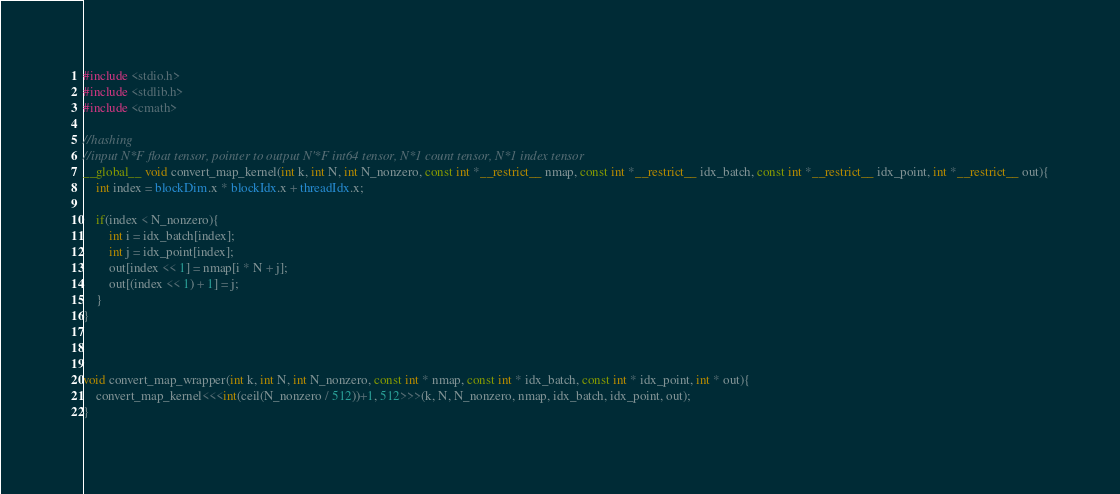<code> <loc_0><loc_0><loc_500><loc_500><_Cuda_>#include <stdio.h>
#include <stdlib.h>
#include <cmath>

//hashing
//input N*F float tensor, pointer to output N'*F int64 tensor, N*1 count tensor, N*1 index tensor
__global__ void convert_map_kernel(int k, int N, int N_nonzero, const int *__restrict__ nmap, const int *__restrict__ idx_batch, const int *__restrict__ idx_point, int *__restrict__ out){
    int index = blockDim.x * blockIdx.x + threadIdx.x;
    
    if(index < N_nonzero){
        int i = idx_batch[index];
        int j = idx_point[index];
        out[index << 1] = nmap[i * N + j];
        out[(index << 1) + 1] = j;
    }
}



void convert_map_wrapper(int k, int N, int N_nonzero, const int * nmap, const int * idx_batch, const int * idx_point, int * out){
    convert_map_kernel<<<int(ceil(N_nonzero / 512))+1, 512>>>(k, N, N_nonzero, nmap, idx_batch, idx_point, out);
}
</code> 